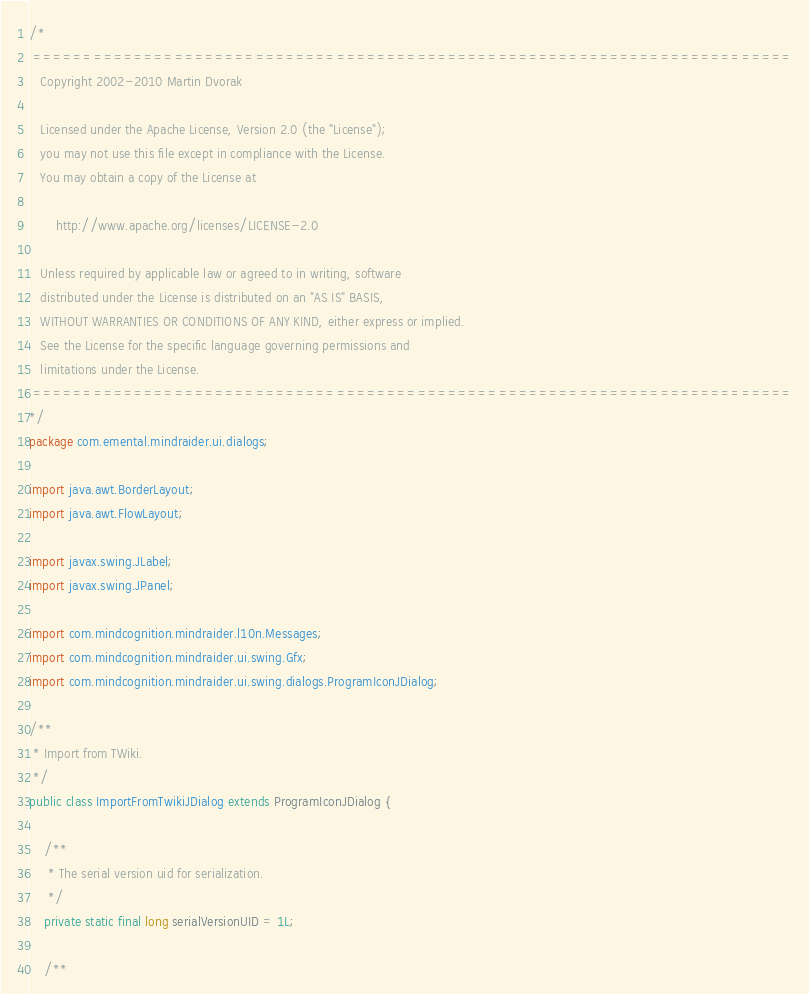Convert code to text. <code><loc_0><loc_0><loc_500><loc_500><_Java_>/*
 ===========================================================================
   Copyright 2002-2010 Martin Dvorak

   Licensed under the Apache License, Version 2.0 (the "License");
   you may not use this file except in compliance with the License.
   You may obtain a copy of the License at

       http://www.apache.org/licenses/LICENSE-2.0

   Unless required by applicable law or agreed to in writing, software
   distributed under the License is distributed on an "AS IS" BASIS,
   WITHOUT WARRANTIES OR CONDITIONS OF ANY KIND, either express or implied.
   See the License for the specific language governing permissions and
   limitations under the License.
 ===========================================================================
*/
package com.emental.mindraider.ui.dialogs;

import java.awt.BorderLayout;
import java.awt.FlowLayout;

import javax.swing.JLabel;
import javax.swing.JPanel;

import com.mindcognition.mindraider.l10n.Messages;
import com.mindcognition.mindraider.ui.swing.Gfx;
import com.mindcognition.mindraider.ui.swing.dialogs.ProgramIconJDialog;

/**
 * Import from TWiki.
 */
public class ImportFromTwikiJDialog extends ProgramIconJDialog {

    /**
     * The serial version uid for serialization.
     */
    private static final long serialVersionUID = 1L;

    /**</code> 